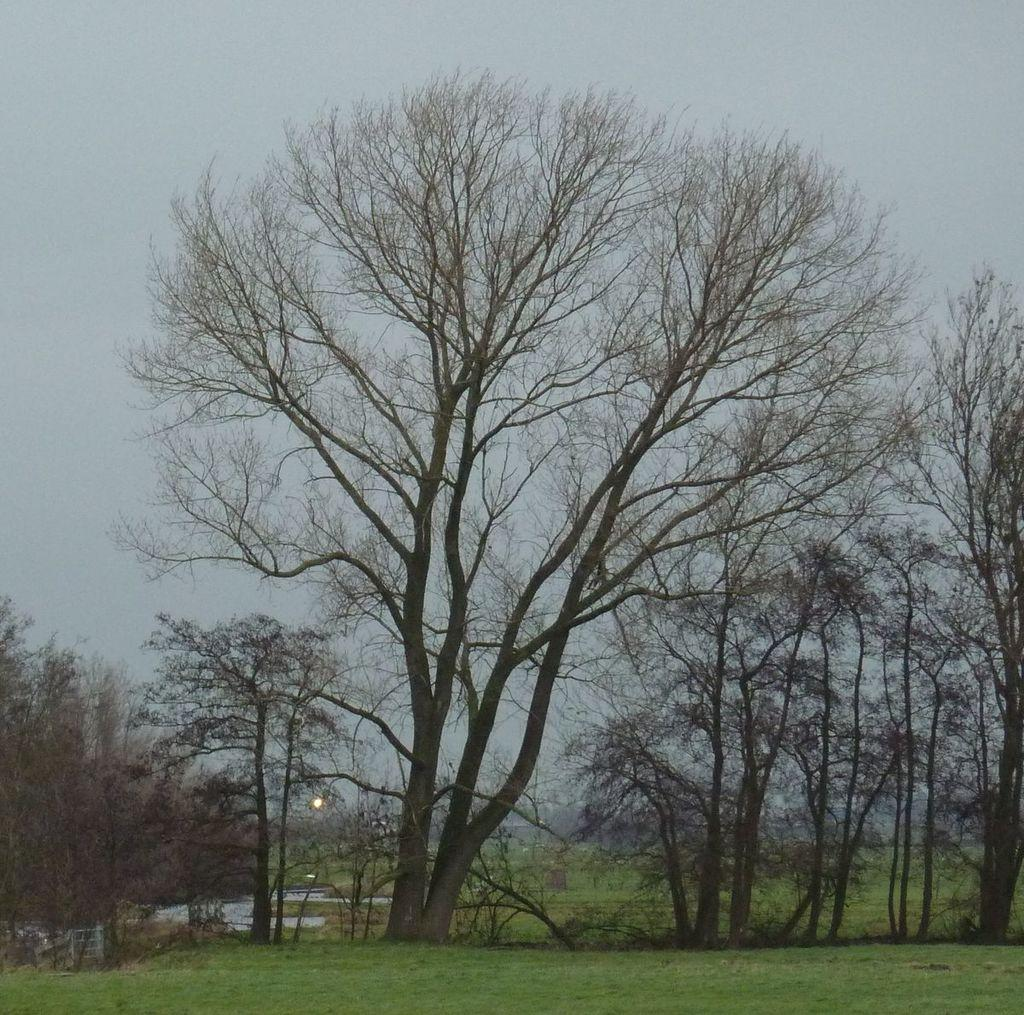What type of vegetation can be seen in the image? There is grass in the image. What other natural elements are present in the image? There are trees in the image. What can be seen in the background of the image? The sky is visible in the background of the image. How does the grass contribute to the wealth of the people in the image? There is no indication in the image of people or their wealth, and the grass is not related to their financial status. 